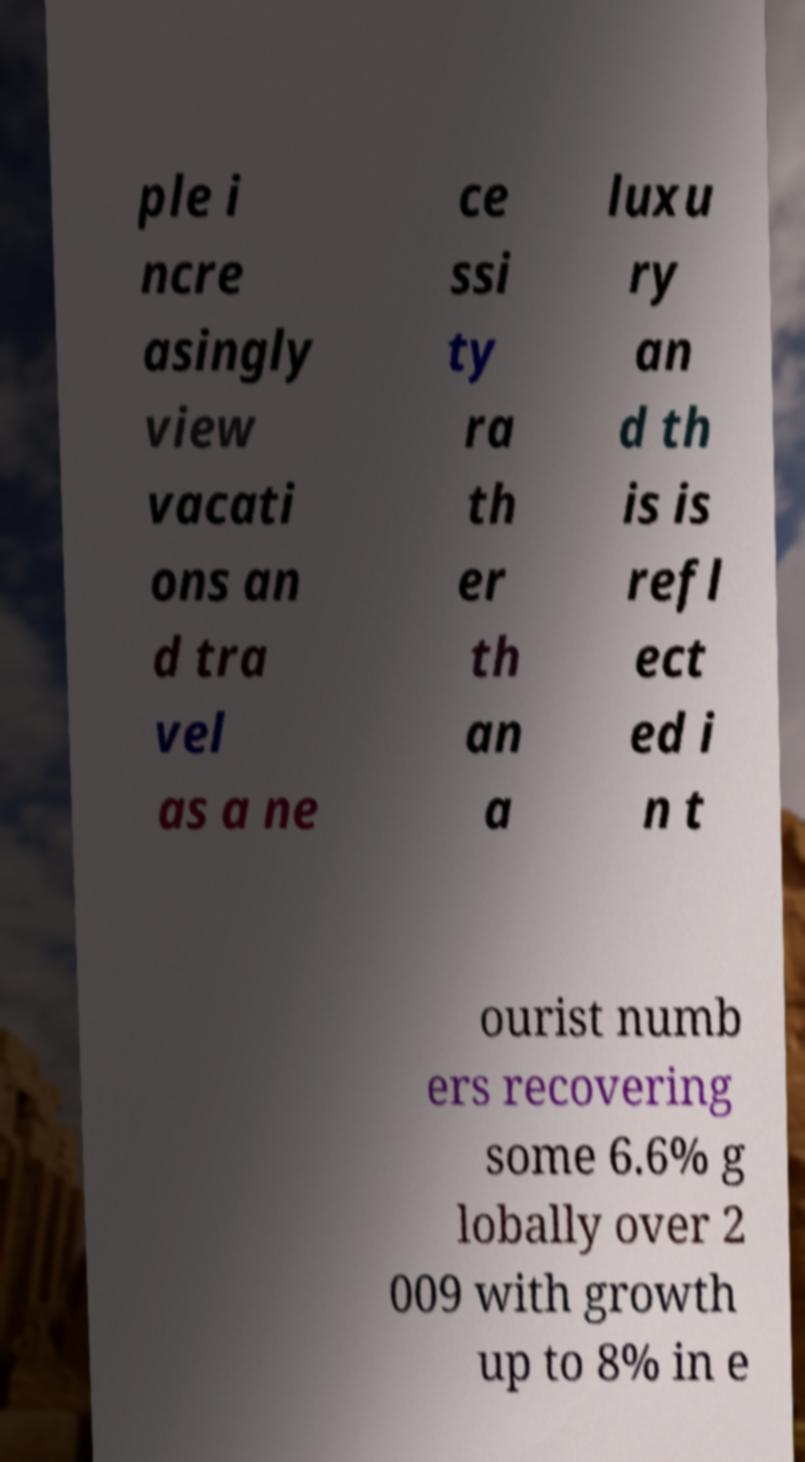Please read and relay the text visible in this image. What does it say? ple i ncre asingly view vacati ons an d tra vel as a ne ce ssi ty ra th er th an a luxu ry an d th is is refl ect ed i n t ourist numb ers recovering some 6.6% g lobally over 2 009 with growth up to 8% in e 